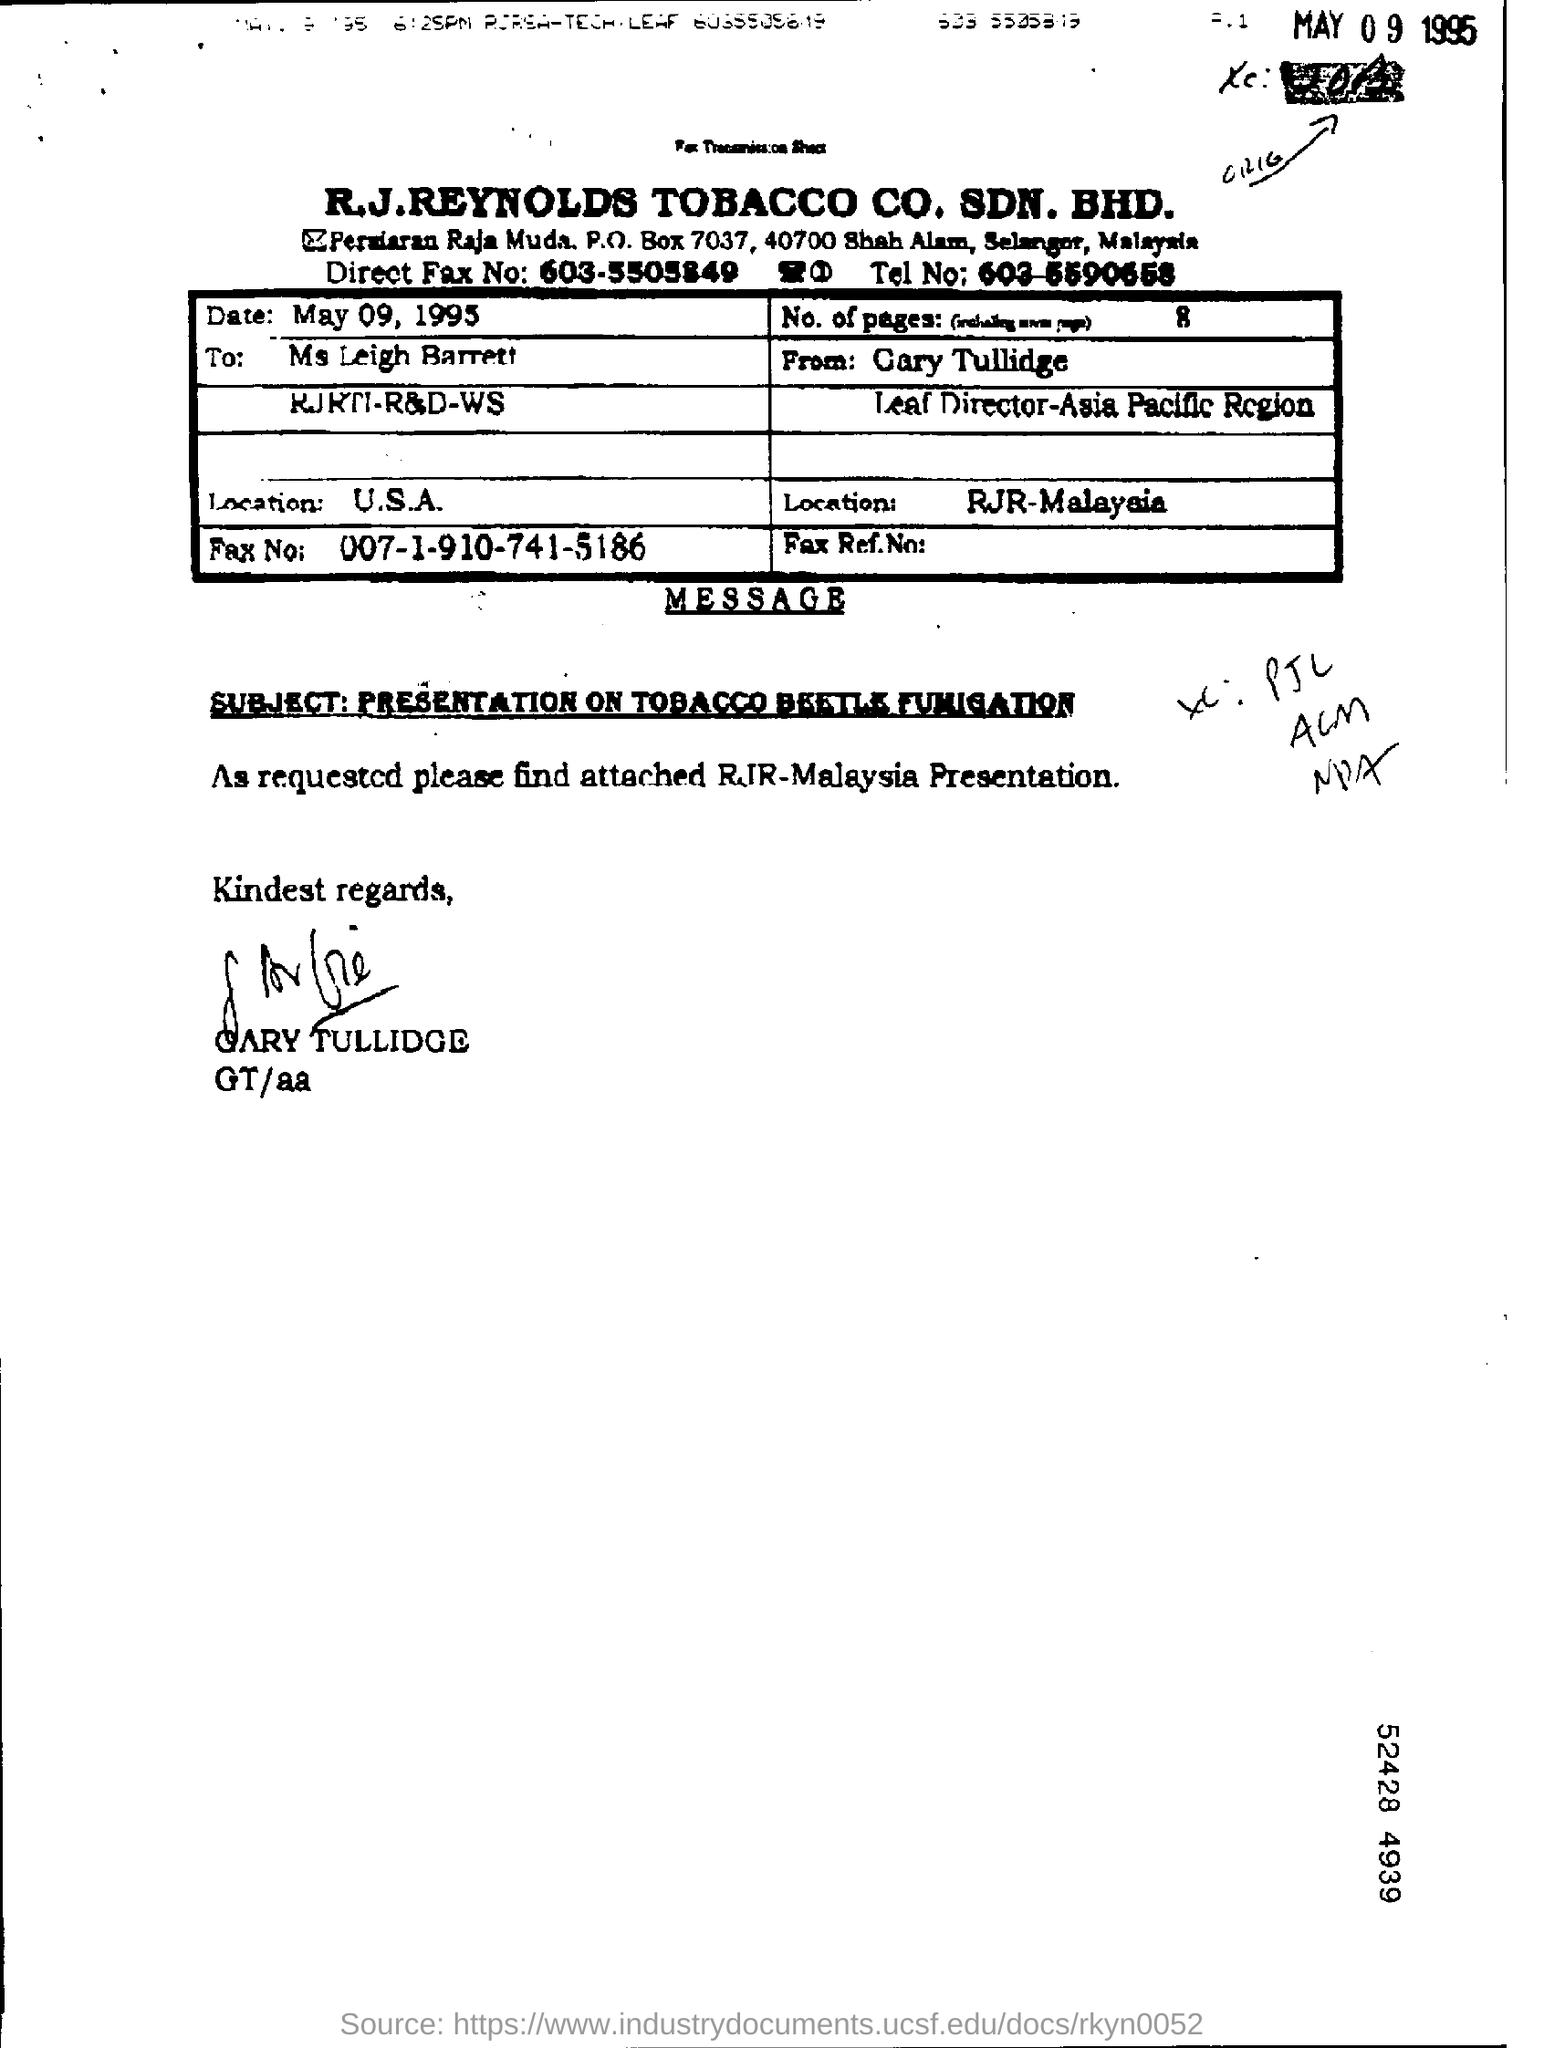Point out several critical features in this image. This letter is addressed to Ms. Leigh Barrett. Ms. Leigh Barrett's fax number is 007-1-910-741-5186. The date is May 09, 1995. 